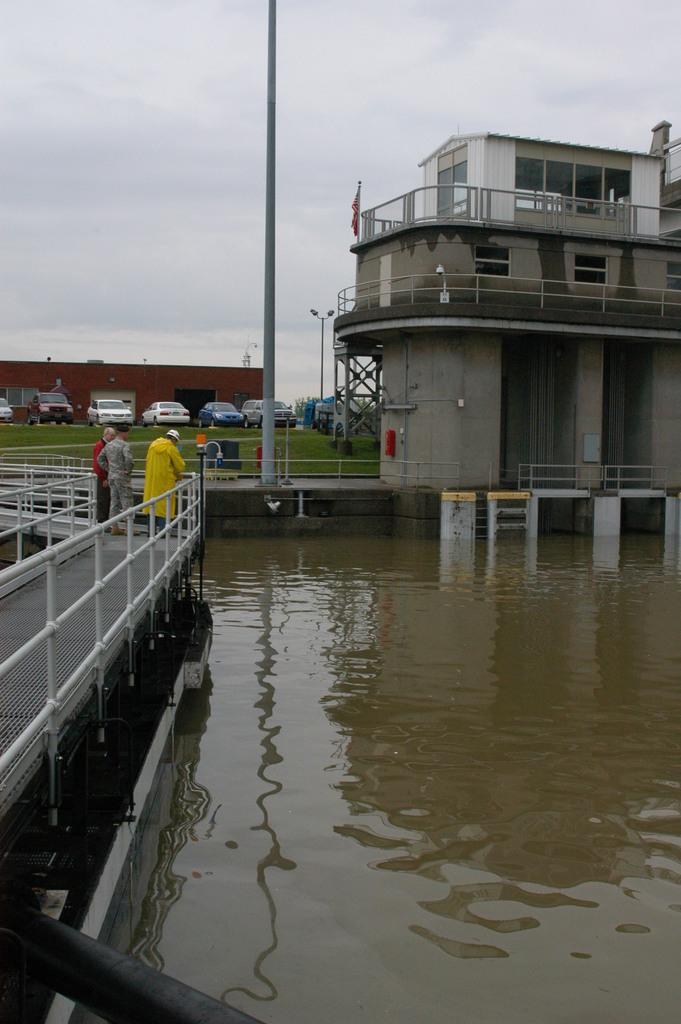Can you describe this image briefly? This image is clicked outside. There is water in the middle. There are some persons on the left side. There is a building on the right side. There are cars in the middle. There is sky at the top. 